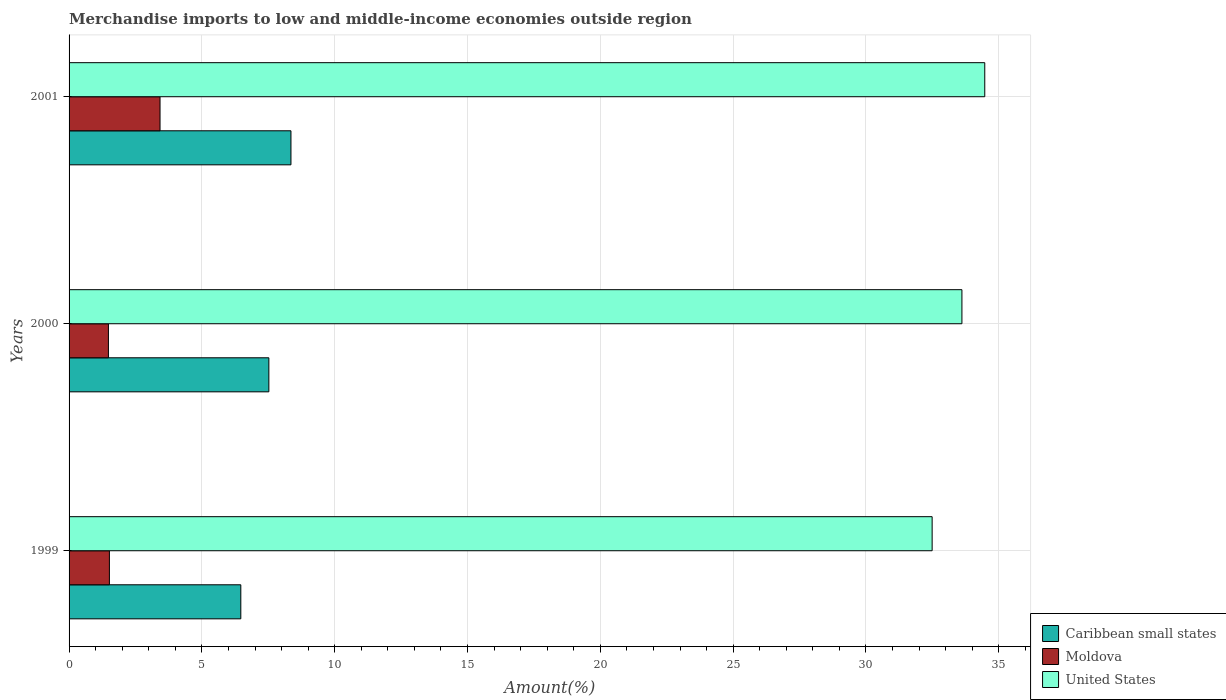Are the number of bars per tick equal to the number of legend labels?
Provide a succinct answer. Yes. Are the number of bars on each tick of the Y-axis equal?
Give a very brief answer. Yes. In how many cases, is the number of bars for a given year not equal to the number of legend labels?
Keep it short and to the point. 0. What is the percentage of amount earned from merchandise imports in Moldova in 2001?
Ensure brevity in your answer.  3.42. Across all years, what is the maximum percentage of amount earned from merchandise imports in Caribbean small states?
Ensure brevity in your answer.  8.35. Across all years, what is the minimum percentage of amount earned from merchandise imports in United States?
Your answer should be very brief. 32.49. In which year was the percentage of amount earned from merchandise imports in Caribbean small states minimum?
Offer a very short reply. 1999. What is the total percentage of amount earned from merchandise imports in United States in the graph?
Your answer should be compact. 100.58. What is the difference between the percentage of amount earned from merchandise imports in Caribbean small states in 1999 and that in 2001?
Your answer should be very brief. -1.89. What is the difference between the percentage of amount earned from merchandise imports in Caribbean small states in 2000 and the percentage of amount earned from merchandise imports in United States in 1999?
Your answer should be very brief. -24.97. What is the average percentage of amount earned from merchandise imports in Caribbean small states per year?
Give a very brief answer. 7.45. In the year 2000, what is the difference between the percentage of amount earned from merchandise imports in Caribbean small states and percentage of amount earned from merchandise imports in United States?
Keep it short and to the point. -26.09. In how many years, is the percentage of amount earned from merchandise imports in Moldova greater than 34 %?
Give a very brief answer. 0. What is the ratio of the percentage of amount earned from merchandise imports in United States in 1999 to that in 2001?
Ensure brevity in your answer.  0.94. What is the difference between the highest and the second highest percentage of amount earned from merchandise imports in Moldova?
Give a very brief answer. 1.91. What is the difference between the highest and the lowest percentage of amount earned from merchandise imports in United States?
Provide a short and direct response. 1.98. What does the 3rd bar from the top in 1999 represents?
Give a very brief answer. Caribbean small states. What does the 3rd bar from the bottom in 2000 represents?
Your answer should be very brief. United States. How many years are there in the graph?
Give a very brief answer. 3. Does the graph contain grids?
Keep it short and to the point. Yes. Where does the legend appear in the graph?
Offer a very short reply. Bottom right. What is the title of the graph?
Offer a terse response. Merchandise imports to low and middle-income economies outside region. What is the label or title of the X-axis?
Your answer should be compact. Amount(%). What is the label or title of the Y-axis?
Your answer should be compact. Years. What is the Amount(%) in Caribbean small states in 1999?
Your answer should be very brief. 6.47. What is the Amount(%) in Moldova in 1999?
Give a very brief answer. 1.52. What is the Amount(%) of United States in 1999?
Make the answer very short. 32.49. What is the Amount(%) in Caribbean small states in 2000?
Your response must be concise. 7.52. What is the Amount(%) in Moldova in 2000?
Provide a short and direct response. 1.48. What is the Amount(%) in United States in 2000?
Provide a succinct answer. 33.61. What is the Amount(%) of Caribbean small states in 2001?
Offer a terse response. 8.35. What is the Amount(%) in Moldova in 2001?
Offer a very short reply. 3.42. What is the Amount(%) of United States in 2001?
Provide a succinct answer. 34.47. Across all years, what is the maximum Amount(%) in Caribbean small states?
Provide a succinct answer. 8.35. Across all years, what is the maximum Amount(%) of Moldova?
Offer a very short reply. 3.42. Across all years, what is the maximum Amount(%) of United States?
Offer a terse response. 34.47. Across all years, what is the minimum Amount(%) in Caribbean small states?
Give a very brief answer. 6.47. Across all years, what is the minimum Amount(%) in Moldova?
Your answer should be very brief. 1.48. Across all years, what is the minimum Amount(%) in United States?
Keep it short and to the point. 32.49. What is the total Amount(%) in Caribbean small states in the graph?
Provide a succinct answer. 22.34. What is the total Amount(%) in Moldova in the graph?
Provide a succinct answer. 6.42. What is the total Amount(%) in United States in the graph?
Provide a succinct answer. 100.58. What is the difference between the Amount(%) of Caribbean small states in 1999 and that in 2000?
Offer a very short reply. -1.06. What is the difference between the Amount(%) in Moldova in 1999 and that in 2000?
Ensure brevity in your answer.  0.04. What is the difference between the Amount(%) of United States in 1999 and that in 2000?
Your response must be concise. -1.12. What is the difference between the Amount(%) in Caribbean small states in 1999 and that in 2001?
Keep it short and to the point. -1.89. What is the difference between the Amount(%) in Moldova in 1999 and that in 2001?
Make the answer very short. -1.91. What is the difference between the Amount(%) in United States in 1999 and that in 2001?
Give a very brief answer. -1.98. What is the difference between the Amount(%) of Caribbean small states in 2000 and that in 2001?
Your response must be concise. -0.83. What is the difference between the Amount(%) in Moldova in 2000 and that in 2001?
Offer a terse response. -1.94. What is the difference between the Amount(%) of United States in 2000 and that in 2001?
Provide a succinct answer. -0.86. What is the difference between the Amount(%) of Caribbean small states in 1999 and the Amount(%) of Moldova in 2000?
Keep it short and to the point. 4.98. What is the difference between the Amount(%) of Caribbean small states in 1999 and the Amount(%) of United States in 2000?
Make the answer very short. -27.15. What is the difference between the Amount(%) of Moldova in 1999 and the Amount(%) of United States in 2000?
Your response must be concise. -32.1. What is the difference between the Amount(%) of Caribbean small states in 1999 and the Amount(%) of Moldova in 2001?
Keep it short and to the point. 3.04. What is the difference between the Amount(%) of Caribbean small states in 1999 and the Amount(%) of United States in 2001?
Your response must be concise. -28.01. What is the difference between the Amount(%) of Moldova in 1999 and the Amount(%) of United States in 2001?
Offer a terse response. -32.96. What is the difference between the Amount(%) in Caribbean small states in 2000 and the Amount(%) in Moldova in 2001?
Make the answer very short. 4.1. What is the difference between the Amount(%) of Caribbean small states in 2000 and the Amount(%) of United States in 2001?
Offer a terse response. -26.95. What is the difference between the Amount(%) of Moldova in 2000 and the Amount(%) of United States in 2001?
Your answer should be compact. -32.99. What is the average Amount(%) of Caribbean small states per year?
Offer a very short reply. 7.45. What is the average Amount(%) in Moldova per year?
Provide a succinct answer. 2.14. What is the average Amount(%) in United States per year?
Ensure brevity in your answer.  33.53. In the year 1999, what is the difference between the Amount(%) of Caribbean small states and Amount(%) of Moldova?
Provide a short and direct response. 4.95. In the year 1999, what is the difference between the Amount(%) in Caribbean small states and Amount(%) in United States?
Offer a very short reply. -26.03. In the year 1999, what is the difference between the Amount(%) in Moldova and Amount(%) in United States?
Offer a very short reply. -30.97. In the year 2000, what is the difference between the Amount(%) of Caribbean small states and Amount(%) of Moldova?
Provide a short and direct response. 6.04. In the year 2000, what is the difference between the Amount(%) of Caribbean small states and Amount(%) of United States?
Make the answer very short. -26.09. In the year 2000, what is the difference between the Amount(%) in Moldova and Amount(%) in United States?
Provide a short and direct response. -32.13. In the year 2001, what is the difference between the Amount(%) in Caribbean small states and Amount(%) in Moldova?
Your answer should be compact. 4.93. In the year 2001, what is the difference between the Amount(%) of Caribbean small states and Amount(%) of United States?
Your answer should be compact. -26.12. In the year 2001, what is the difference between the Amount(%) of Moldova and Amount(%) of United States?
Keep it short and to the point. -31.05. What is the ratio of the Amount(%) in Caribbean small states in 1999 to that in 2000?
Your answer should be very brief. 0.86. What is the ratio of the Amount(%) in Moldova in 1999 to that in 2000?
Your response must be concise. 1.03. What is the ratio of the Amount(%) in United States in 1999 to that in 2000?
Offer a terse response. 0.97. What is the ratio of the Amount(%) of Caribbean small states in 1999 to that in 2001?
Provide a short and direct response. 0.77. What is the ratio of the Amount(%) of Moldova in 1999 to that in 2001?
Make the answer very short. 0.44. What is the ratio of the Amount(%) of United States in 1999 to that in 2001?
Offer a terse response. 0.94. What is the ratio of the Amount(%) of Caribbean small states in 2000 to that in 2001?
Your response must be concise. 0.9. What is the ratio of the Amount(%) in Moldova in 2000 to that in 2001?
Ensure brevity in your answer.  0.43. What is the ratio of the Amount(%) in United States in 2000 to that in 2001?
Provide a short and direct response. 0.98. What is the difference between the highest and the second highest Amount(%) of Caribbean small states?
Your response must be concise. 0.83. What is the difference between the highest and the second highest Amount(%) of Moldova?
Keep it short and to the point. 1.91. What is the difference between the highest and the second highest Amount(%) in United States?
Provide a short and direct response. 0.86. What is the difference between the highest and the lowest Amount(%) of Caribbean small states?
Ensure brevity in your answer.  1.89. What is the difference between the highest and the lowest Amount(%) in Moldova?
Provide a short and direct response. 1.94. What is the difference between the highest and the lowest Amount(%) of United States?
Give a very brief answer. 1.98. 